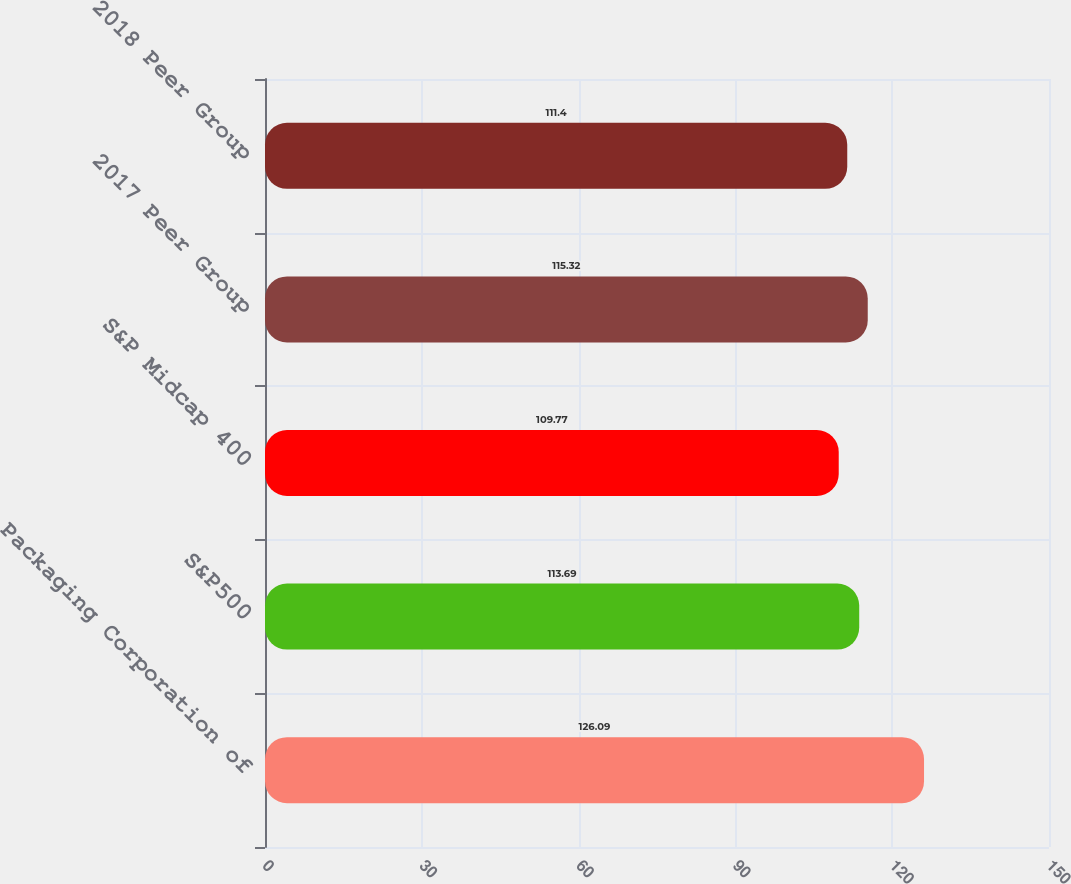Convert chart to OTSL. <chart><loc_0><loc_0><loc_500><loc_500><bar_chart><fcel>Packaging Corporation of<fcel>S&P500<fcel>S&P Midcap 400<fcel>2017 Peer Group<fcel>2018 Peer Group<nl><fcel>126.09<fcel>113.69<fcel>109.77<fcel>115.32<fcel>111.4<nl></chart> 